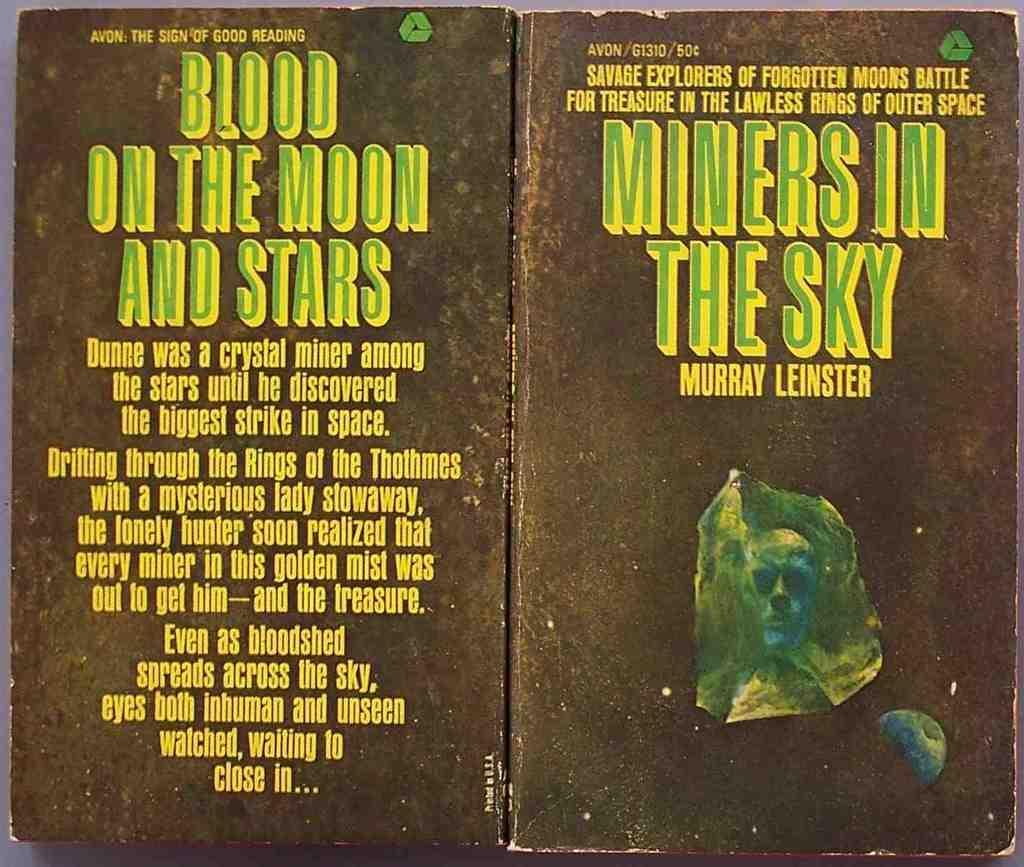<image>
Summarize the visual content of the image. A black, green, and yellow book titled Miners In The Sky. 